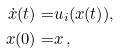Convert formula to latex. <formula><loc_0><loc_0><loc_500><loc_500>\dot { x } ( t ) = & u _ { i } ( x ( t ) ) , \\ x ( 0 ) = & x \, ,</formula> 